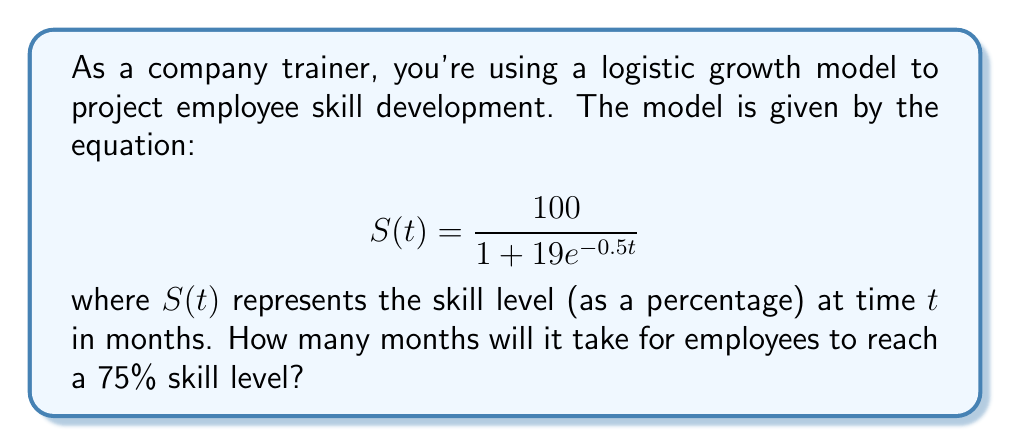Show me your answer to this math problem. To solve this problem, we need to follow these steps:

1) We want to find $t$ when $S(t) = 75$. So, let's set up the equation:

   $$75 = \frac{100}{1 + 19e^{-0.5t}}$$

2) Multiply both sides by $(1 + 19e^{-0.5t})$:

   $$75(1 + 19e^{-0.5t}) = 100$$

3) Distribute on the left side:

   $$75 + 1425e^{-0.5t} = 100$$

4) Subtract 75 from both sides:

   $$1425e^{-0.5t} = 25$$

5) Divide both sides by 1425:

   $$e^{-0.5t} = \frac{25}{1425} = \frac{1}{57}$$

6) Take the natural log of both sides:

   $$-0.5t = \ln(\frac{1}{57})$$

7) Divide both sides by -0.5:

   $$t = -\frac{\ln(\frac{1}{57})}{0.5} = \frac{\ln(57)}{0.5}$$

8) Calculate the result:

   $$t = \frac{4.04305}{0.5} \approx 8.0861$$

9) Since time must be in whole months, we round up to the nearest month.
Answer: 9 months 